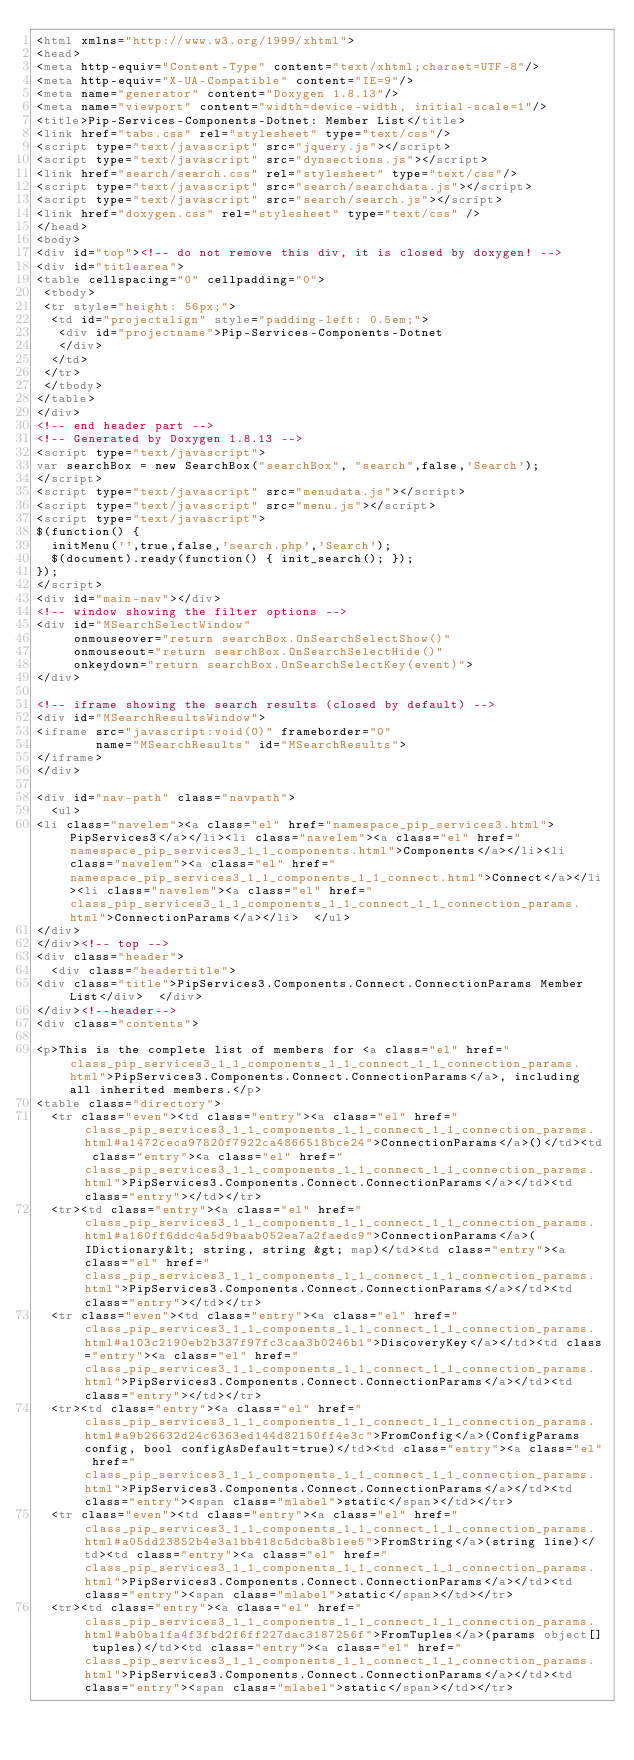Convert code to text. <code><loc_0><loc_0><loc_500><loc_500><_HTML_><html xmlns="http://www.w3.org/1999/xhtml">
<head>
<meta http-equiv="Content-Type" content="text/xhtml;charset=UTF-8"/>
<meta http-equiv="X-UA-Compatible" content="IE=9"/>
<meta name="generator" content="Doxygen 1.8.13"/>
<meta name="viewport" content="width=device-width, initial-scale=1"/>
<title>Pip-Services-Components-Dotnet: Member List</title>
<link href="tabs.css" rel="stylesheet" type="text/css"/>
<script type="text/javascript" src="jquery.js"></script>
<script type="text/javascript" src="dynsections.js"></script>
<link href="search/search.css" rel="stylesheet" type="text/css"/>
<script type="text/javascript" src="search/searchdata.js"></script>
<script type="text/javascript" src="search/search.js"></script>
<link href="doxygen.css" rel="stylesheet" type="text/css" />
</head>
<body>
<div id="top"><!-- do not remove this div, it is closed by doxygen! -->
<div id="titlearea">
<table cellspacing="0" cellpadding="0">
 <tbody>
 <tr style="height: 56px;">
  <td id="projectalign" style="padding-left: 0.5em;">
   <div id="projectname">Pip-Services-Components-Dotnet
   </div>
  </td>
 </tr>
 </tbody>
</table>
</div>
<!-- end header part -->
<!-- Generated by Doxygen 1.8.13 -->
<script type="text/javascript">
var searchBox = new SearchBox("searchBox", "search",false,'Search');
</script>
<script type="text/javascript" src="menudata.js"></script>
<script type="text/javascript" src="menu.js"></script>
<script type="text/javascript">
$(function() {
  initMenu('',true,false,'search.php','Search');
  $(document).ready(function() { init_search(); });
});
</script>
<div id="main-nav"></div>
<!-- window showing the filter options -->
<div id="MSearchSelectWindow"
     onmouseover="return searchBox.OnSearchSelectShow()"
     onmouseout="return searchBox.OnSearchSelectHide()"
     onkeydown="return searchBox.OnSearchSelectKey(event)">
</div>

<!-- iframe showing the search results (closed by default) -->
<div id="MSearchResultsWindow">
<iframe src="javascript:void(0)" frameborder="0" 
        name="MSearchResults" id="MSearchResults">
</iframe>
</div>

<div id="nav-path" class="navpath">
  <ul>
<li class="navelem"><a class="el" href="namespace_pip_services3.html">PipServices3</a></li><li class="navelem"><a class="el" href="namespace_pip_services3_1_1_components.html">Components</a></li><li class="navelem"><a class="el" href="namespace_pip_services3_1_1_components_1_1_connect.html">Connect</a></li><li class="navelem"><a class="el" href="class_pip_services3_1_1_components_1_1_connect_1_1_connection_params.html">ConnectionParams</a></li>  </ul>
</div>
</div><!-- top -->
<div class="header">
  <div class="headertitle">
<div class="title">PipServices3.Components.Connect.ConnectionParams Member List</div>  </div>
</div><!--header-->
<div class="contents">

<p>This is the complete list of members for <a class="el" href="class_pip_services3_1_1_components_1_1_connect_1_1_connection_params.html">PipServices3.Components.Connect.ConnectionParams</a>, including all inherited members.</p>
<table class="directory">
  <tr class="even"><td class="entry"><a class="el" href="class_pip_services3_1_1_components_1_1_connect_1_1_connection_params.html#a1472ceca97820f7922ca4866518bce24">ConnectionParams</a>()</td><td class="entry"><a class="el" href="class_pip_services3_1_1_components_1_1_connect_1_1_connection_params.html">PipServices3.Components.Connect.ConnectionParams</a></td><td class="entry"></td></tr>
  <tr><td class="entry"><a class="el" href="class_pip_services3_1_1_components_1_1_connect_1_1_connection_params.html#a160ff6ddc4a5d9baab052ea7a2faedc9">ConnectionParams</a>(IDictionary&lt; string, string &gt; map)</td><td class="entry"><a class="el" href="class_pip_services3_1_1_components_1_1_connect_1_1_connection_params.html">PipServices3.Components.Connect.ConnectionParams</a></td><td class="entry"></td></tr>
  <tr class="even"><td class="entry"><a class="el" href="class_pip_services3_1_1_components_1_1_connect_1_1_connection_params.html#a103c2190eb2b337f97fc3caa3b0246b1">DiscoveryKey</a></td><td class="entry"><a class="el" href="class_pip_services3_1_1_components_1_1_connect_1_1_connection_params.html">PipServices3.Components.Connect.ConnectionParams</a></td><td class="entry"></td></tr>
  <tr><td class="entry"><a class="el" href="class_pip_services3_1_1_components_1_1_connect_1_1_connection_params.html#a9b26632d24c6363ed144d82150ff4e3c">FromConfig</a>(ConfigParams config, bool configAsDefault=true)</td><td class="entry"><a class="el" href="class_pip_services3_1_1_components_1_1_connect_1_1_connection_params.html">PipServices3.Components.Connect.ConnectionParams</a></td><td class="entry"><span class="mlabel">static</span></td></tr>
  <tr class="even"><td class="entry"><a class="el" href="class_pip_services3_1_1_components_1_1_connect_1_1_connection_params.html#a05dd23852b4e3a1bb418c5dcba8b1ee5">FromString</a>(string line)</td><td class="entry"><a class="el" href="class_pip_services3_1_1_components_1_1_connect_1_1_connection_params.html">PipServices3.Components.Connect.ConnectionParams</a></td><td class="entry"><span class="mlabel">static</span></td></tr>
  <tr><td class="entry"><a class="el" href="class_pip_services3_1_1_components_1_1_connect_1_1_connection_params.html#ab0ba1fa4f3fbd2f6ff227dac3187256f">FromTuples</a>(params object[] tuples)</td><td class="entry"><a class="el" href="class_pip_services3_1_1_components_1_1_connect_1_1_connection_params.html">PipServices3.Components.Connect.ConnectionParams</a></td><td class="entry"><span class="mlabel">static</span></td></tr></code> 